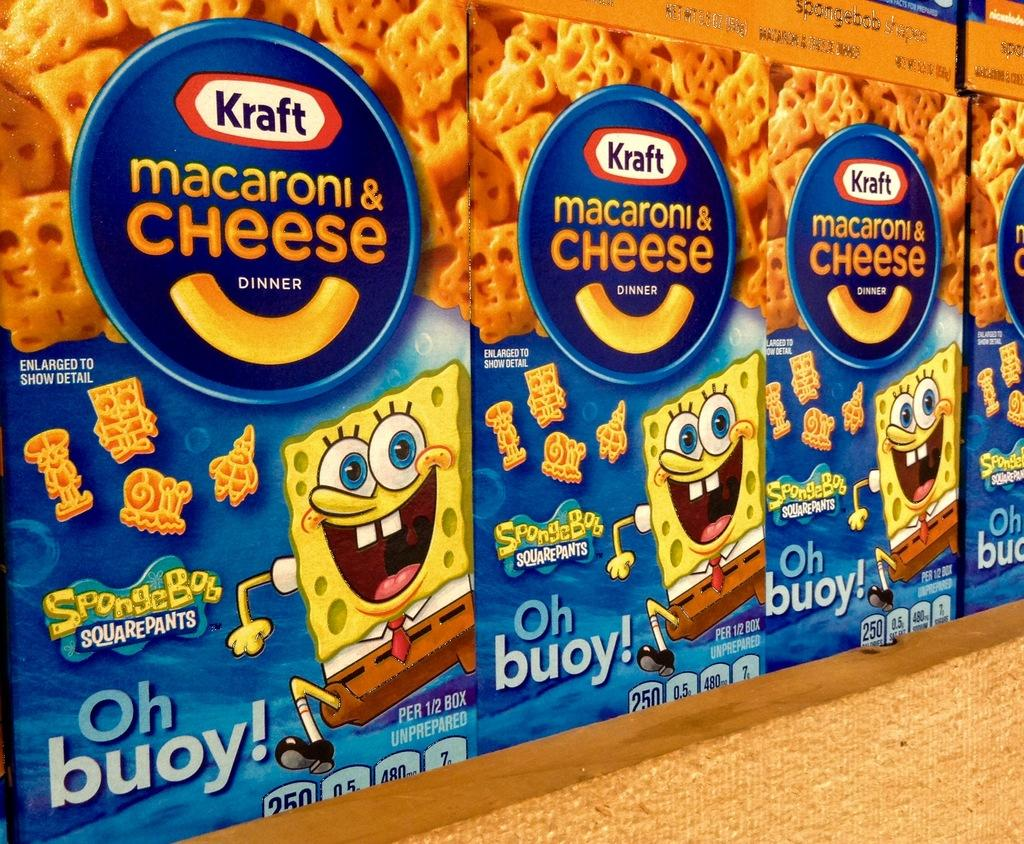What objects are present in the image? There are boxes in the image. What can be seen on the surface of the boxes? The boxes have printed text and animated pictures on them. What type of image is visible on the boxes? A view of a food item is visible on the boxes. Are there any insects crawling on the boxes in the image? There is no mention of insects in the provided facts, so we cannot determine if there are any insects present in the image. 